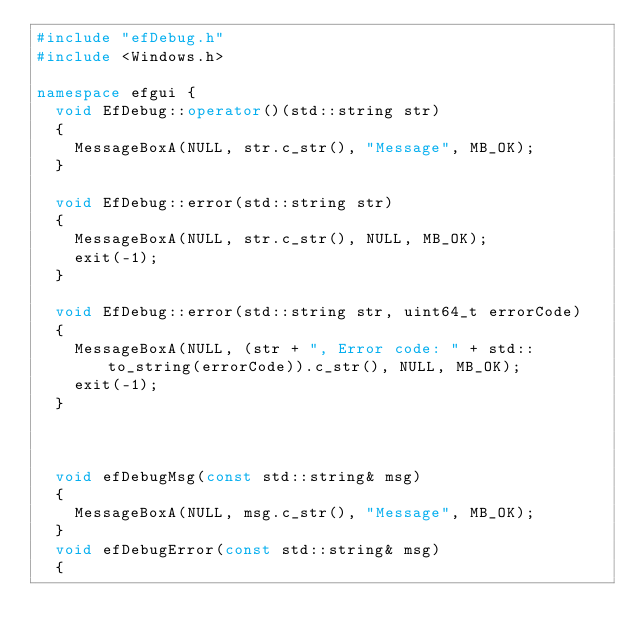Convert code to text. <code><loc_0><loc_0><loc_500><loc_500><_C++_>#include "efDebug.h"
#include <Windows.h>

namespace efgui {
	void EfDebug::operator()(std::string str)
	{
		MessageBoxA(NULL, str.c_str(), "Message", MB_OK);
	}

	void EfDebug::error(std::string str)
	{
		MessageBoxA(NULL, str.c_str(), NULL, MB_OK);
		exit(-1);
	}

	void EfDebug::error(std::string str, uint64_t errorCode)
	{
		MessageBoxA(NULL, (str + ", Error code: " + std::to_string(errorCode)).c_str(), NULL, MB_OK);
		exit(-1);
	}



	void efDebugMsg(const std::string& msg)
	{
		MessageBoxA(NULL, msg.c_str(), "Message", MB_OK);
	}
	void efDebugError(const std::string& msg)
	{</code> 